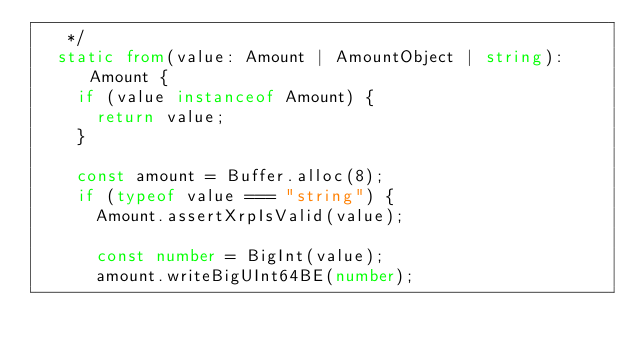Convert code to text. <code><loc_0><loc_0><loc_500><loc_500><_TypeScript_>   */
  static from(value: Amount | AmountObject | string): Amount {
    if (value instanceof Amount) {
      return value;
    }

    const amount = Buffer.alloc(8);
    if (typeof value === "string") {
      Amount.assertXrpIsValid(value);

      const number = BigInt(value);
      amount.writeBigUInt64BE(number);
</code> 